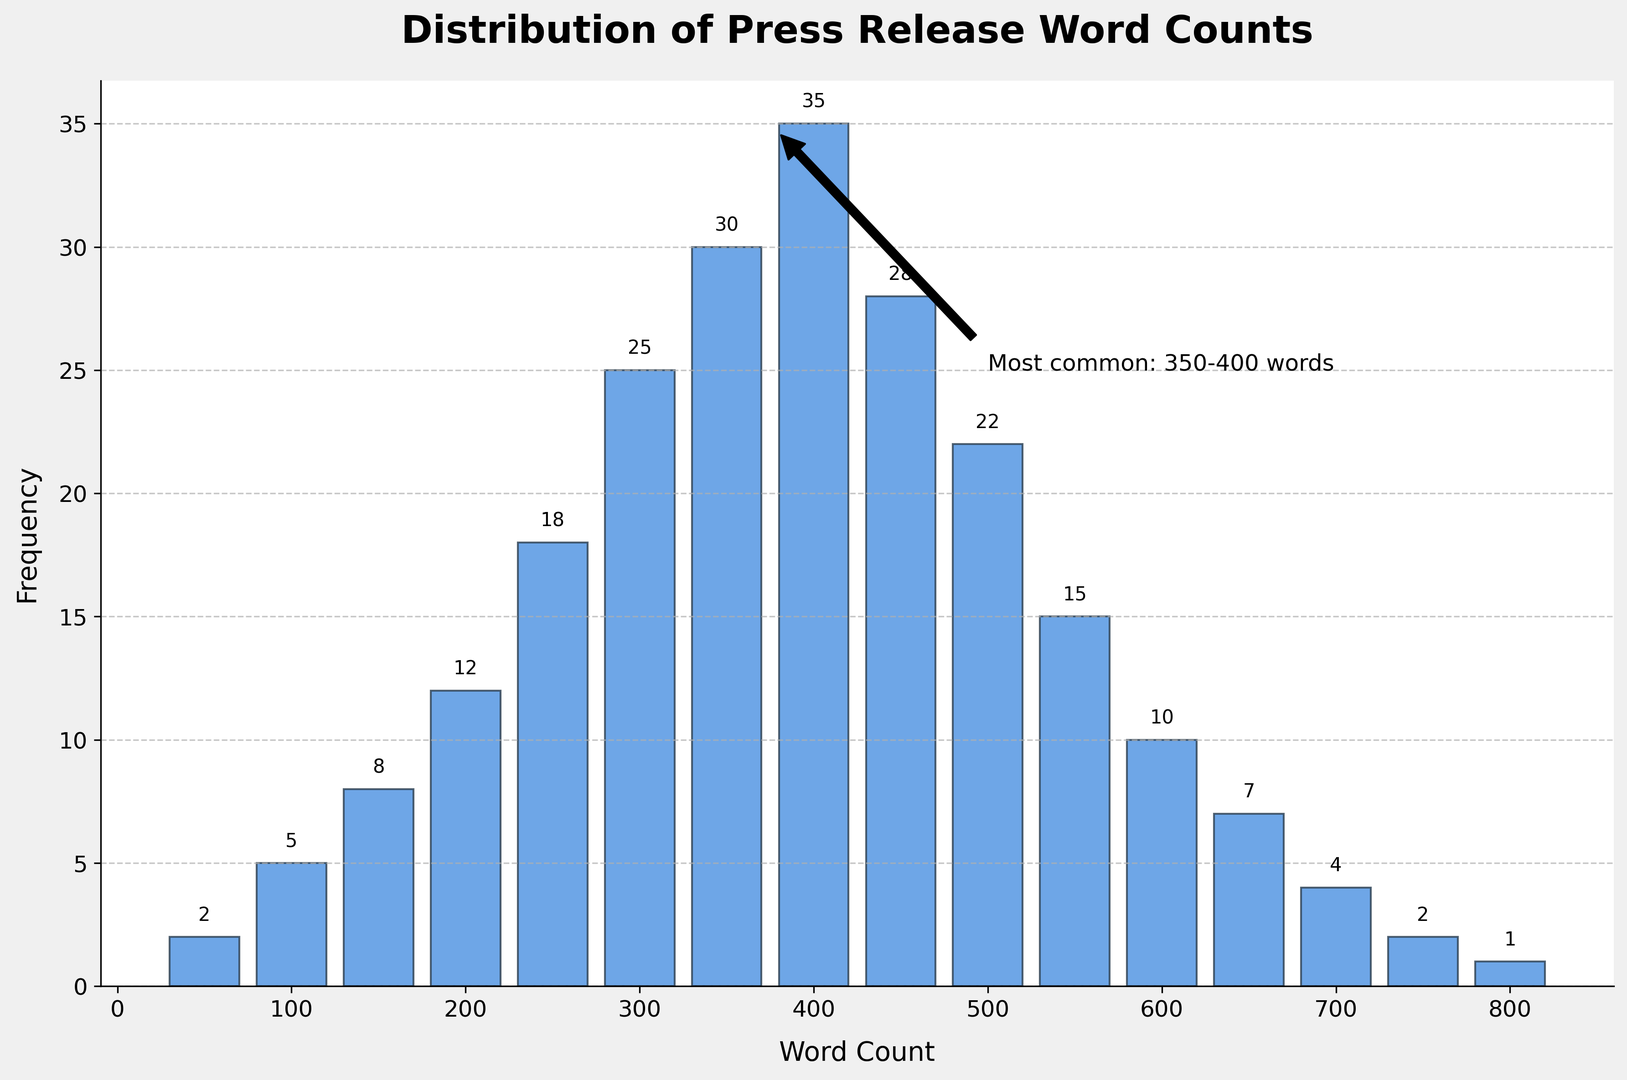What word count range has the highest frequency? The word count range with the highest frequency corresponds to the height of the tallest bar. The tallest bar is for the word count range between 350 and 400 words, which has a frequency of 35.
Answer: 350-400 words How many press releases have word counts between 200 and 400 words? To find the number of press releases in this range, sum the frequencies for word counts 200, 250, 300, 350, and 400. The frequencies are 12, 18, 25, 30, and 35 respectively, summing up to 120.
Answer: 120 Is the frequency higher for word counts of 500 or 600? By comparing the heights of the bars for word counts of 500 and 600, we see that the frequency is higher for 500 (22) compared to 600 (10).
Answer: 500 What is the total count of press releases that have word counts fewer than 200 words? Sum the frequencies of word counts 50, 100, 150, and 200. The frequencies are 2, 5, 8, and 12 respectively, giving a total of 27.
Answer: 27 How does the frequency of press releases with 450 words compare to those with 400 words? The bar for 450 words has a frequency of 28, while the bar for 400 words has a frequency of 35. Therefore, the frequency for 450 words is lower than that for 400 words.
Answer: Lower What is the frequency for word counts ranging from 700 to 800 words? The frequencies for 700, 750, and 800 words are 4, 2, and 1 respectively. Summing these up, we get 7.
Answer: 7 Are there more press releases with word counts of 300 or 500? The bar for 300 words has a frequency of 25, while the bar for 500 words has a frequency of 22. Therefore, there are more press releases with 300 words.
Answer: 300 What is the combined frequency of press releases with word counts between 450 and 600 words? Sum the frequencies for word counts 450, 500, 550, and 600. The frequencies are 28, 22, 15, and 10 respectively, summing up to 75.
Answer: 75 